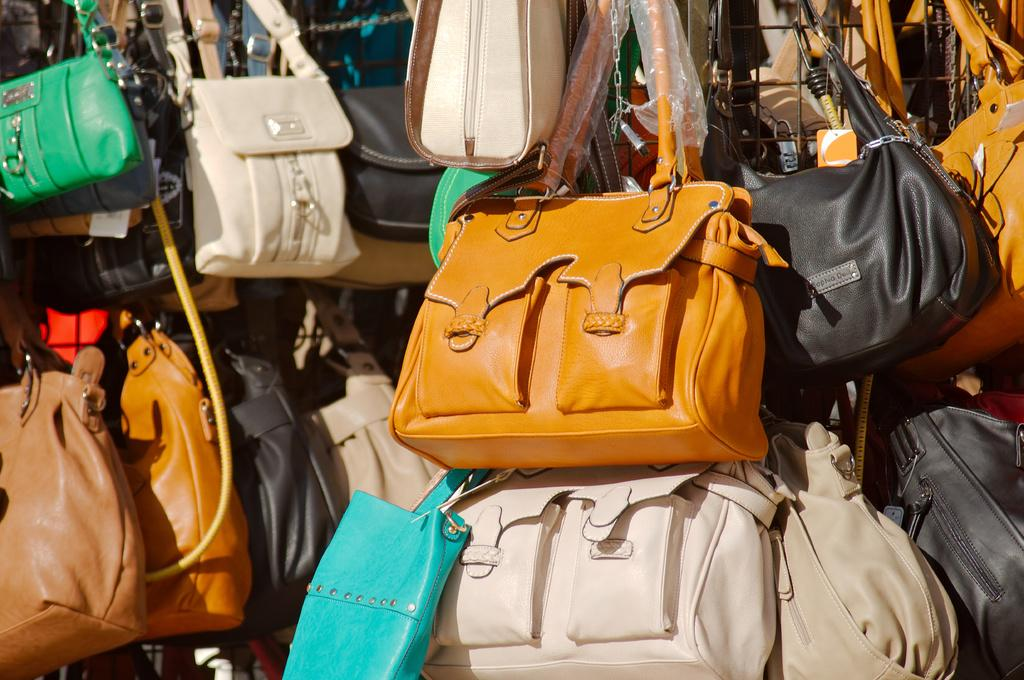What type of items are featured in the image? There are many handbags in the image. Can you describe the variety of the handbags? The handbags are in different colors. What specific colors are mentioned in the image? The colors mentioned in the image are brown, white, green, blue, and black. Are there any chickens or turkeys visible in the image? No, there are no chickens or turkeys present in the image; it features handbags in different colors. Is anyone reading a book in the image? There is no indication of anyone reading a book in the image, as it focuses on handbags in different colors. 